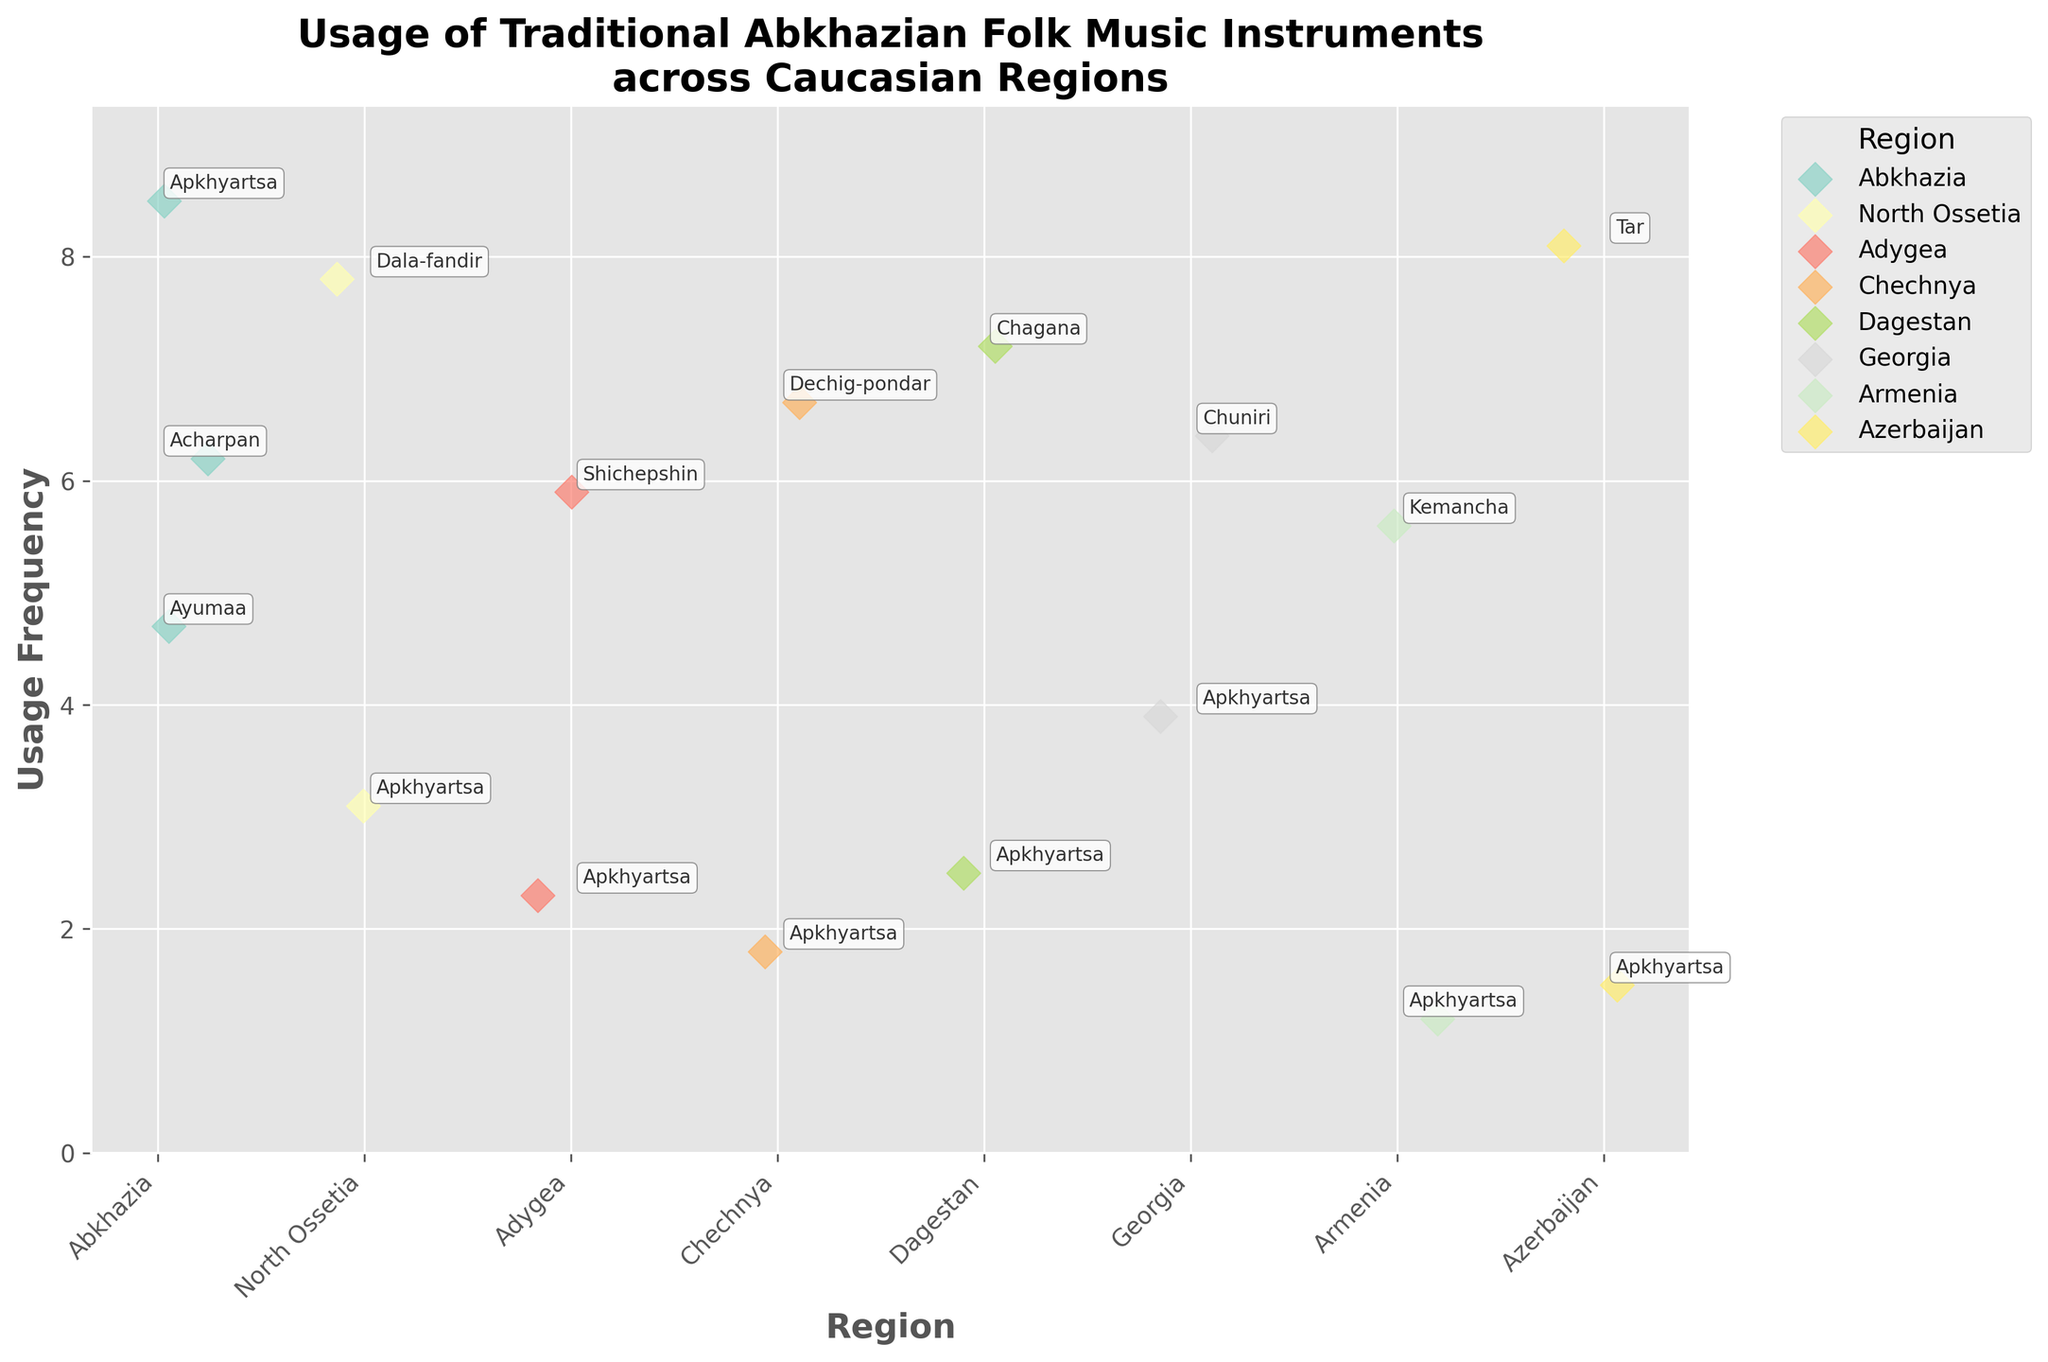What is the title of the figure? The title is usually located at the top of the figure and is clearly visible.
Answer: Usage of Traditional Abkhazian Folk Music Instruments across Caucasian Regions Which region shows the highest usage frequency for the Apkhyartsa instrument? By visually inspecting the plot, identify which region has the highest dot for the 'Apkhyartsa' instrument.
Answer: Abkhazia What is the average usage frequency of the Apkhyartsa instrument across all regions? Sum the usage frequencies for Apkhyartsa across all regions and divide by the number of regions listed. Sum: 8.5 + 3.1 + 2.3 + 1.8 + 2.5 + 3.9 + 1.2 + 1.5 = 24.8. Divide by 8 regions: 24.8 / 8 = 3.1
Answer: 3.1 Which region has the highest overall usage frequency of a single instrument, and which instrument is it? Inspect the plot for the highest data point and note the corresponding region and instrument.
Answer: Abkhazia, Apkhyartsa How does the usage frequency of Apkhyartsa in North Ossetia compare to its usage in Adygea? Find and compare the y-values (usage frequencies) for Apkhyartsa in North Ossetia and Adygea.
Answer: Higher in North Ossetia Which region has the most diverse range of traditional instruments based on the figure? Count the number of different instruments plotted for each region and identify the region with the most unique instruments.
Answer: Dagestan Calculate the difference in usage frequency of the Apkhyartsa instrument between Georgia and Armenia. Subtract the usage frequency of Apkhyartsa in Armenia from its frequency in Georgia. 3.9 - 1.2 = 2.7
Answer: 2.7 Identify the region with the lowest usage frequency for Apkhyartsa and provide the frequency. Find the lowest data point for Apkhyartsa across all regions on the plot.
Answer: Armenia, 1.2 What is the most frequently used instrument in Azerbaijan based on the figure? Observe the plot for Azerbaijan and identify which instrument has the highest usage frequency data point.
Answer: Tar 